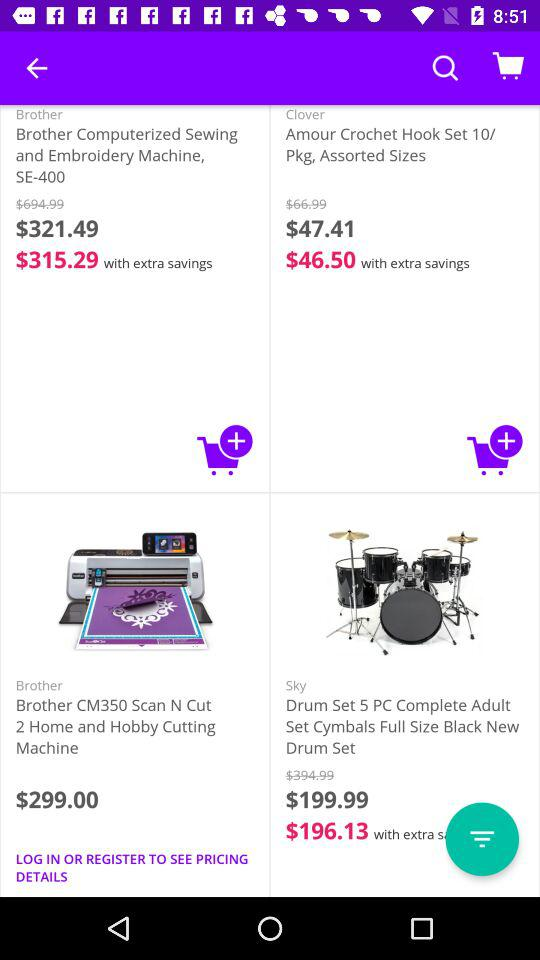Which items are provided in "Beauty Gifts"?
When the provided information is insufficient, respond with <no answer>. <no answer> 